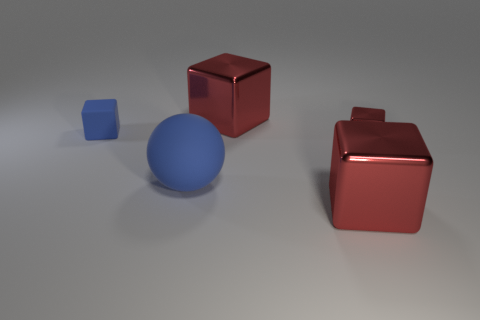What shape is the blue rubber object on the right side of the blue cube?
Keep it short and to the point. Sphere. What is the color of the large metallic cube in front of the rubber thing behind the small red metallic cube that is behind the large rubber object?
Your response must be concise. Red. Do the tiny blue rubber thing and the big blue rubber thing have the same shape?
Your answer should be compact. No. Are there the same number of rubber things that are behind the big matte thing and small blue things?
Offer a terse response. Yes. What number of other objects are the same material as the blue sphere?
Provide a succinct answer. 1. There is a red object that is in front of the large blue rubber ball; is it the same size as the metal thing that is behind the small red metallic block?
Your answer should be very brief. Yes. How many objects are matte things on the right side of the blue rubber block or red metallic objects behind the tiny red metal cube?
Your answer should be compact. 2. Are there any other things that are the same shape as the big blue matte object?
Make the answer very short. No. There is a small metallic block that is behind the big rubber object; does it have the same color as the object in front of the large blue rubber sphere?
Your response must be concise. Yes. How many rubber objects are cyan cubes or spheres?
Your response must be concise. 1. 